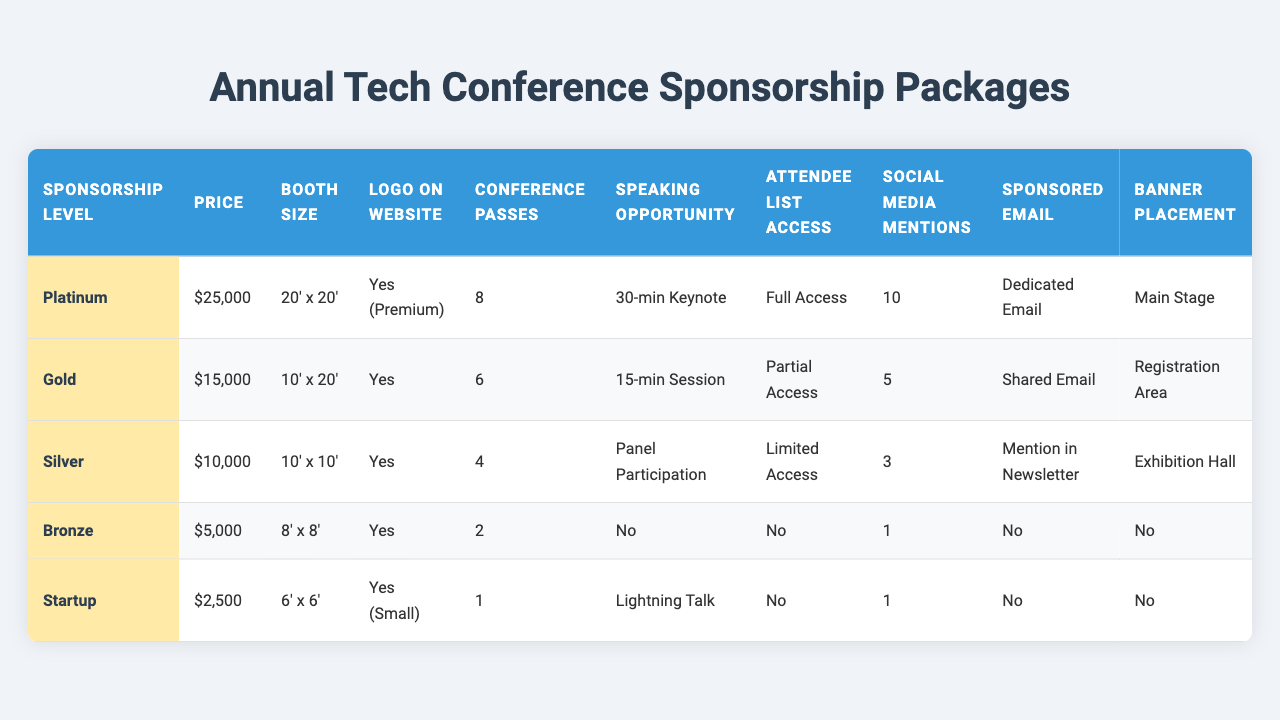What is the price of the Gold sponsorship package? The table lists the price for the Gold sponsorship package directly in the "Price" column, which shows '$15,000'.
Answer: $15,000 How many conference passes does the Silver package include? The "Conference Passes" column for the Silver package indicates that it includes '4' passes.
Answer: 4 Which sponsorship level offers the largest booth size? By comparing the "Booth Size" column, the Platinum sponsorship level has the largest booth size at '20' x 20'.
Answer: Platinum Is there a speaking opportunity provided with the Bronze package? The "Speaking Opportunity" column for the Bronze package states 'No', indicating there is no speaking opportunity.
Answer: No What is the total number of conference passes offered by all packages combined? Summing the conference passes: 8 (Platinum) + 6 (Gold) + 4 (Silver) + 2 (Bronze) + 1 (Startup) = 21.
Answer: 21 Which sponsorship levels have access to the attendee list? Checking the "Attendee List Access" column, the Platinum, Gold, and Silver packages have access while Bronze and Startup do not.
Answer: Platinum, Gold, Silver What is the difference in price between the Platinum and Startup packages? The Platinum package costs $25,000, and the Startup package costs $2,500. The difference is $25,000 - $2,500 = $22,500.
Answer: $22,500 Which package provides the most social media mentions? Looking at the "Social Media Mentions" column, the Platinum package offers '10', which is the highest.
Answer: Platinum Are there any sponsorship packages that offer no banner placement? The Bronze and Startup packages both show 'No' in the "Banner Placement" column, indicating they do not offer this feature.
Answer: Yes If a company chooses the Gold sponsorship package, how many speaking opportunities do they have? The "Speaking Opportunity" column for the Gold package indicates a '15-min Session', which is a specific speaking opportunity provided.
Answer: 15-min Session What sponsorship level offers the least amount of conference passes? The "Conference Passes" column shows that the Startup package offers only '1', which is the least among all levels.
Answer: Startup 